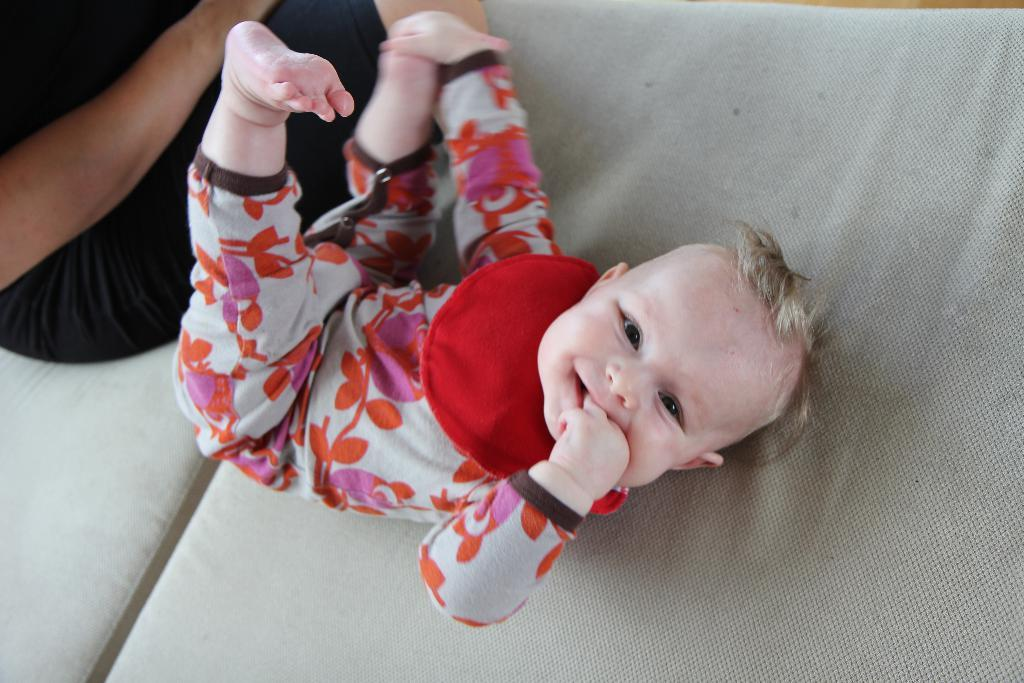What is the main subject of the picture? The main subject of the picture is a baby. Where is the baby located in the image? The baby is lying on a bed. Is there anyone else in the picture with the baby? Yes, there is a person sitting beside the baby. What type of plant is being used for division in the picture? There is no plant or division present in the image; it features a baby lying on a bed with a person sitting beside them. 